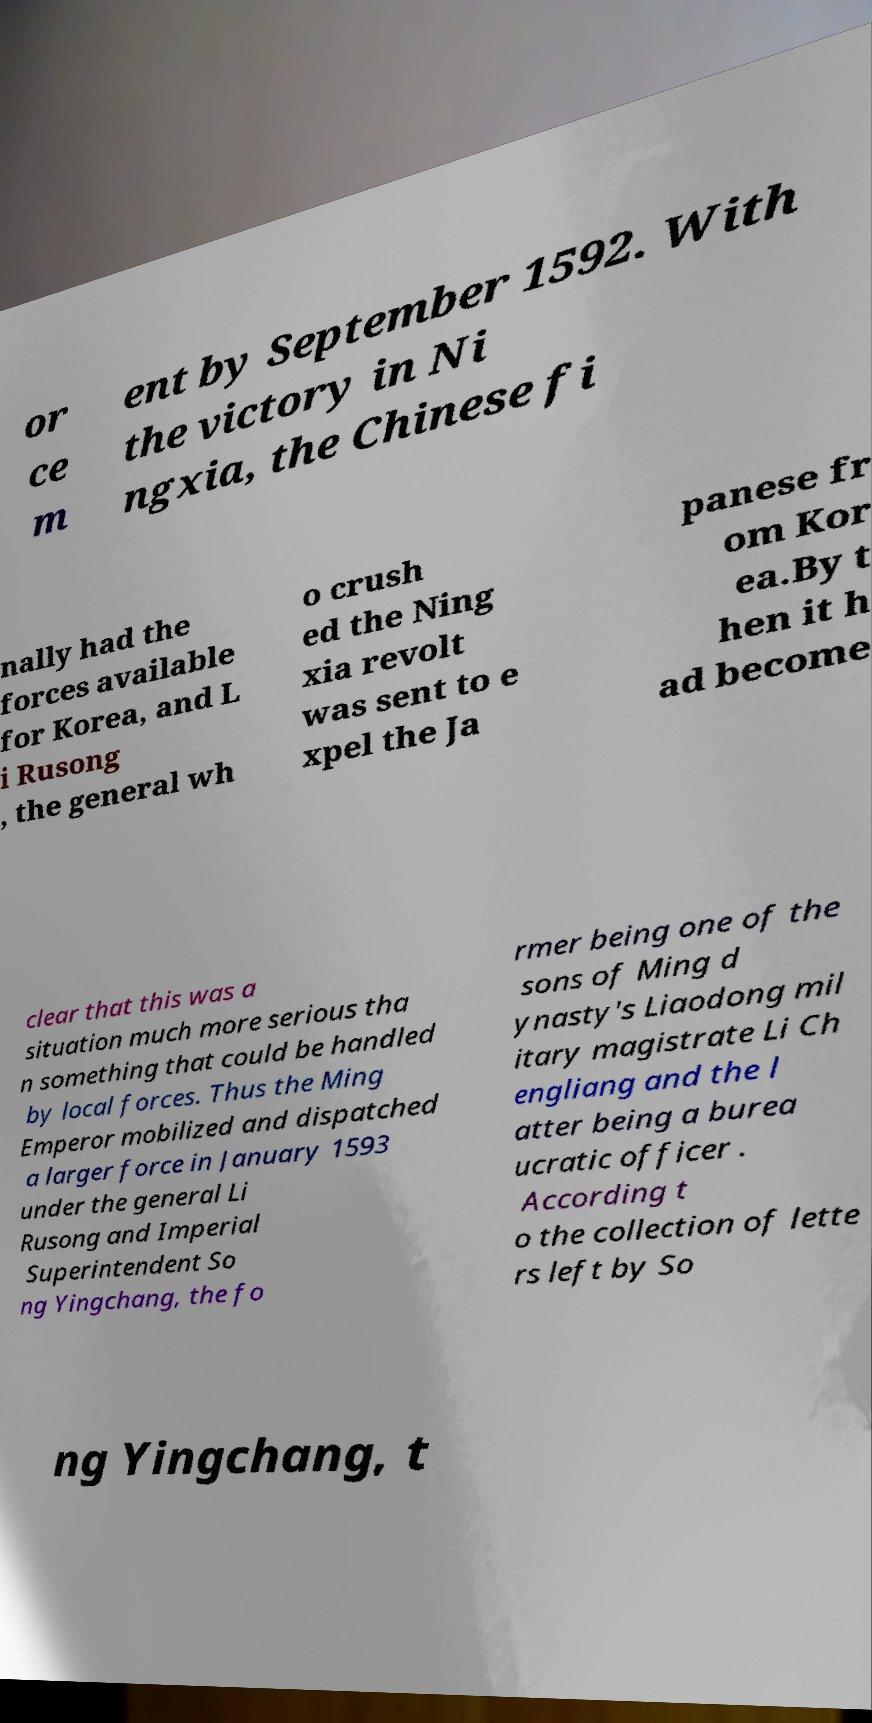Please identify and transcribe the text found in this image. or ce m ent by September 1592. With the victory in Ni ngxia, the Chinese fi nally had the forces available for Korea, and L i Rusong , the general wh o crush ed the Ning xia revolt was sent to e xpel the Ja panese fr om Kor ea.By t hen it h ad become clear that this was a situation much more serious tha n something that could be handled by local forces. Thus the Ming Emperor mobilized and dispatched a larger force in January 1593 under the general Li Rusong and Imperial Superintendent So ng Yingchang, the fo rmer being one of the sons of Ming d ynasty's Liaodong mil itary magistrate Li Ch engliang and the l atter being a burea ucratic officer . According t o the collection of lette rs left by So ng Yingchang, t 